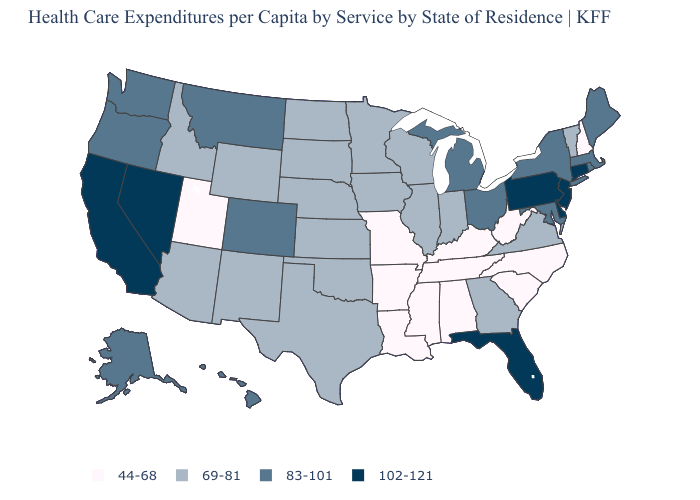What is the lowest value in the Northeast?
Give a very brief answer. 44-68. Among the states that border Arizona , which have the highest value?
Be succinct. California, Nevada. What is the value of Massachusetts?
Concise answer only. 83-101. Does the map have missing data?
Short answer required. No. Which states have the highest value in the USA?
Be succinct. California, Connecticut, Delaware, Florida, Nevada, New Jersey, Pennsylvania. What is the value of South Carolina?
Concise answer only. 44-68. Name the states that have a value in the range 69-81?
Give a very brief answer. Arizona, Georgia, Idaho, Illinois, Indiana, Iowa, Kansas, Minnesota, Nebraska, New Mexico, North Dakota, Oklahoma, South Dakota, Texas, Vermont, Virginia, Wisconsin, Wyoming. What is the value of Kansas?
Write a very short answer. 69-81. Does Wisconsin have a higher value than Arkansas?
Keep it brief. Yes. Name the states that have a value in the range 44-68?
Answer briefly. Alabama, Arkansas, Kentucky, Louisiana, Mississippi, Missouri, New Hampshire, North Carolina, South Carolina, Tennessee, Utah, West Virginia. Name the states that have a value in the range 44-68?
Be succinct. Alabama, Arkansas, Kentucky, Louisiana, Mississippi, Missouri, New Hampshire, North Carolina, South Carolina, Tennessee, Utah, West Virginia. Which states have the lowest value in the USA?
Answer briefly. Alabama, Arkansas, Kentucky, Louisiana, Mississippi, Missouri, New Hampshire, North Carolina, South Carolina, Tennessee, Utah, West Virginia. What is the highest value in the USA?
Short answer required. 102-121. Does Texas have a higher value than Kentucky?
Keep it brief. Yes. Among the states that border Wisconsin , which have the highest value?
Short answer required. Michigan. 